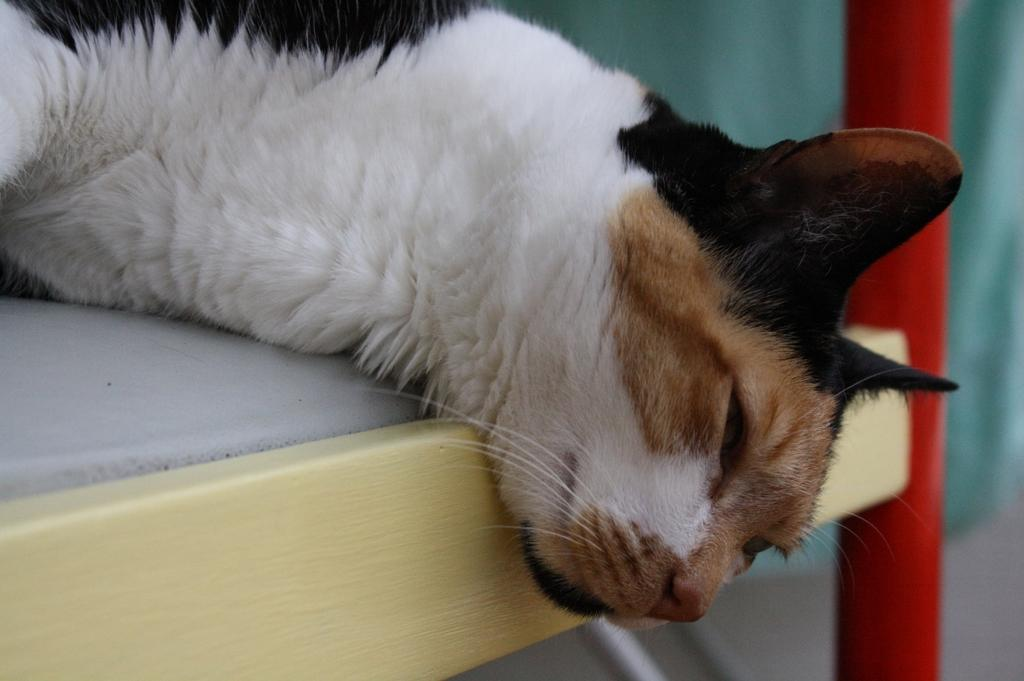What type of animal is in the image? There is a cat in the image. What is the cat doing in the image? The cat is lying on an object. Can you describe the background of the image? The background of the image is blurred. What is the title of the book the maid is reading in the image? There is no book or maid present in the image; it features a cat lying on an object with a blurred background. 